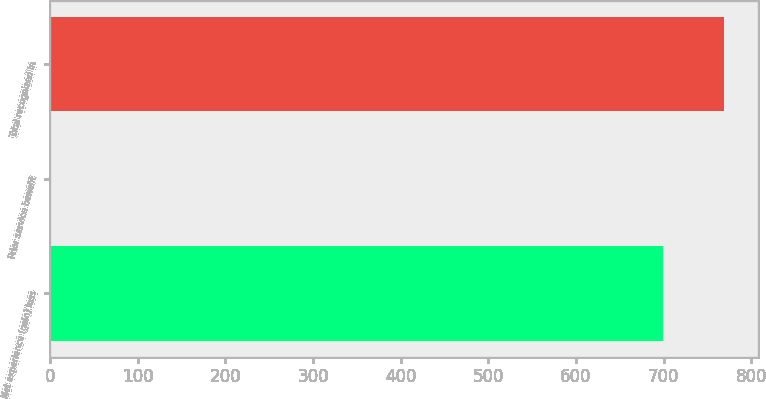<chart> <loc_0><loc_0><loc_500><loc_500><bar_chart><fcel>Net experience (gain) loss<fcel>Prior service benefit<fcel>Total recognized in<nl><fcel>699<fcel>1<fcel>768.9<nl></chart> 